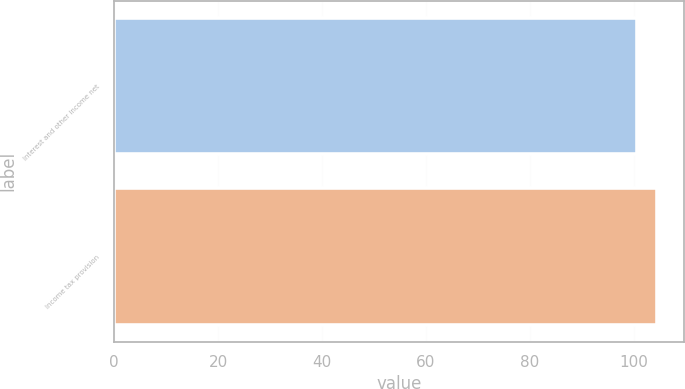Convert chart to OTSL. <chart><loc_0><loc_0><loc_500><loc_500><bar_chart><fcel>Interest and other income net<fcel>Income tax provision<nl><fcel>100.7<fcel>104.4<nl></chart> 